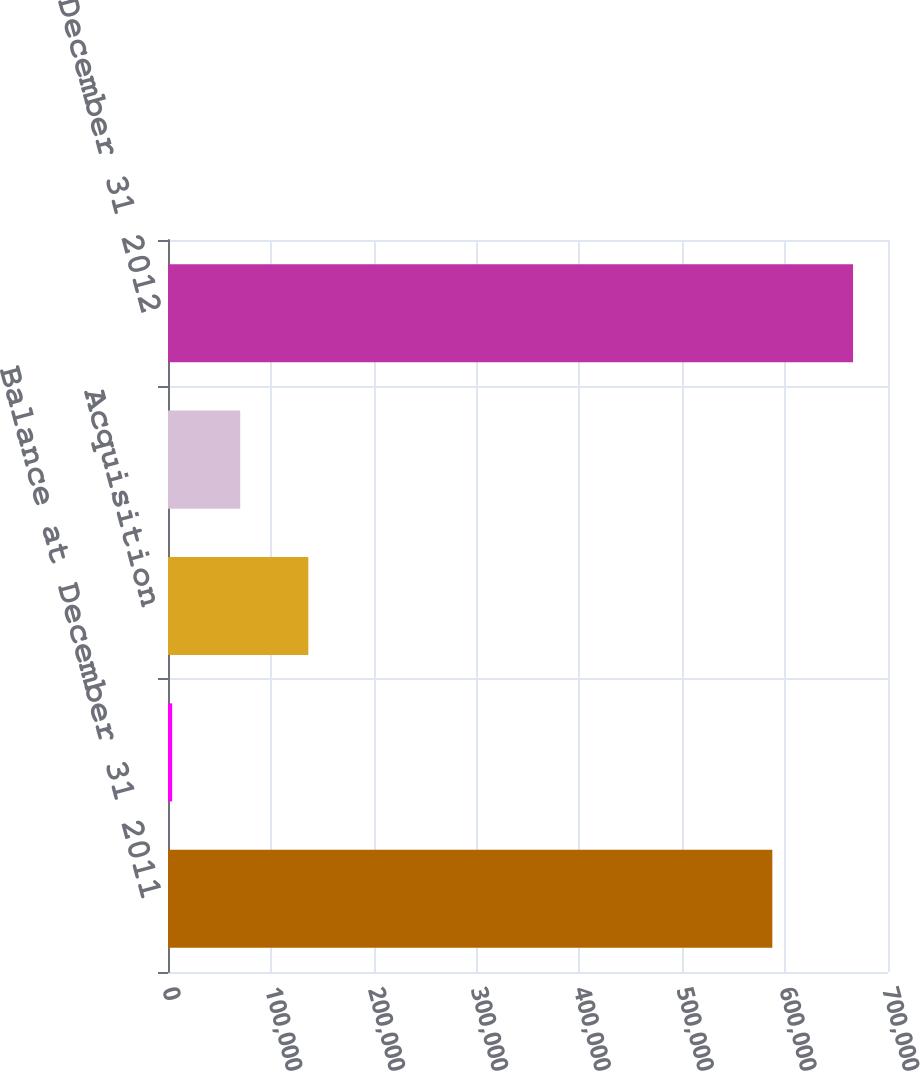Convert chart to OTSL. <chart><loc_0><loc_0><loc_500><loc_500><bar_chart><fcel>Balance at December 31 2011<fcel>Adjustment to preliminary<fcel>Acquisition<fcel>Foreign currency impact<fcel>Balance at December 31 2012<nl><fcel>587531<fcel>4024<fcel>136424<fcel>70223.8<fcel>666022<nl></chart> 